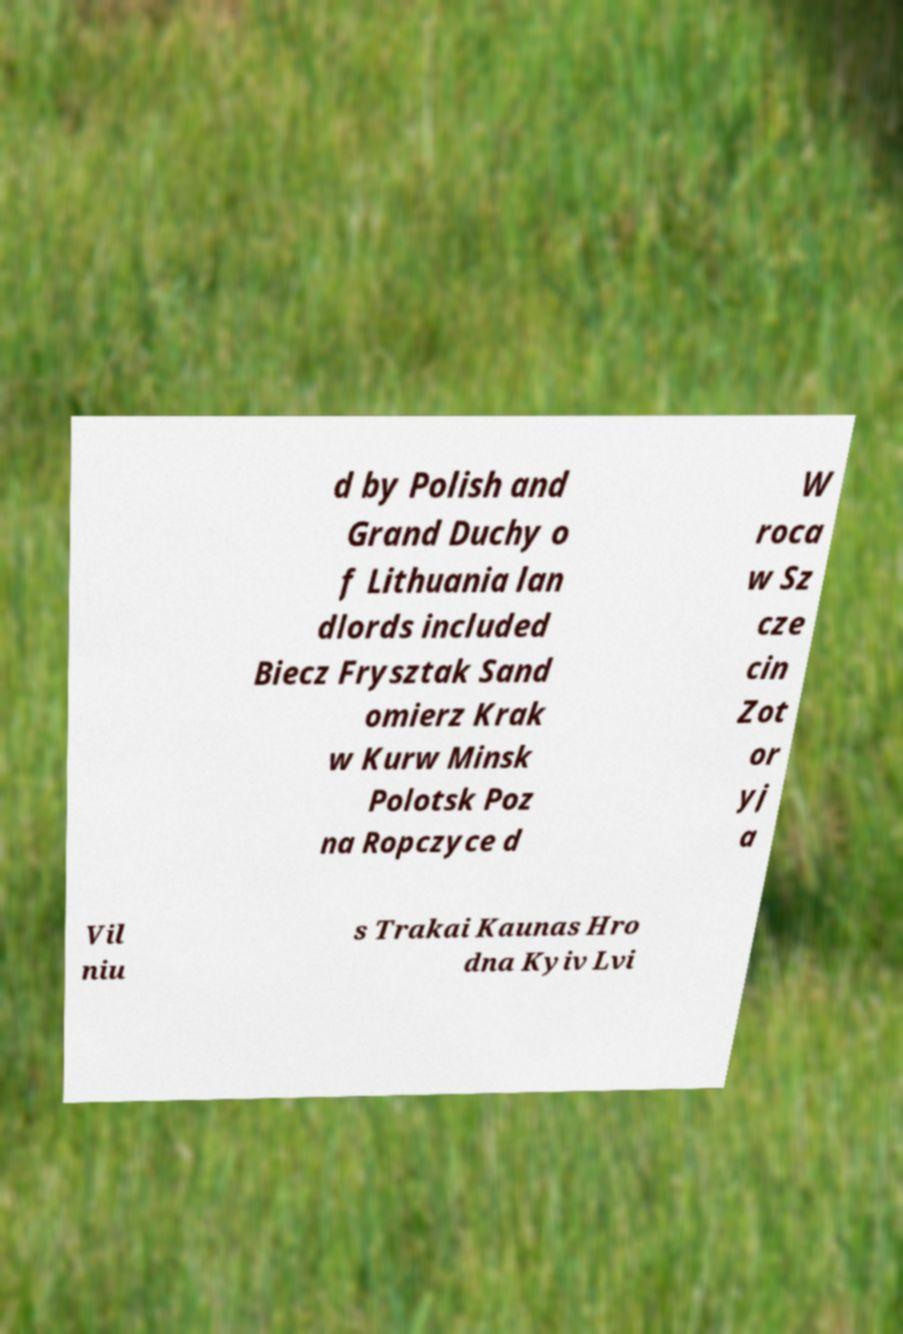Please read and relay the text visible in this image. What does it say? d by Polish and Grand Duchy o f Lithuania lan dlords included Biecz Frysztak Sand omierz Krak w Kurw Minsk Polotsk Poz na Ropczyce d W roca w Sz cze cin Zot or yj a Vil niu s Trakai Kaunas Hro dna Kyiv Lvi 